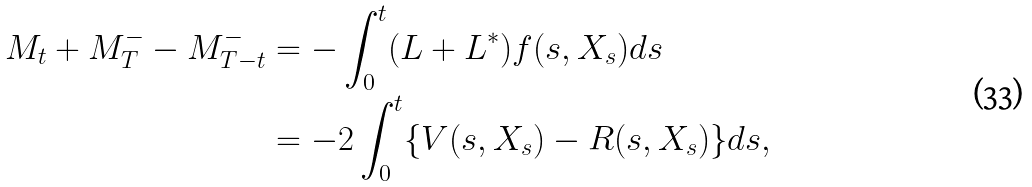<formula> <loc_0><loc_0><loc_500><loc_500>M _ { t } + M _ { T } ^ { - } - M _ { T - t } ^ { - } & = - \int _ { 0 } ^ { t } ( L + L ^ { * } ) f ( s , X _ { s } ) d s \\ & = - 2 \int _ { 0 } ^ { t } \{ V ( s , X _ { s } ) - R ( s , X _ { s } ) \} d s ,</formula> 